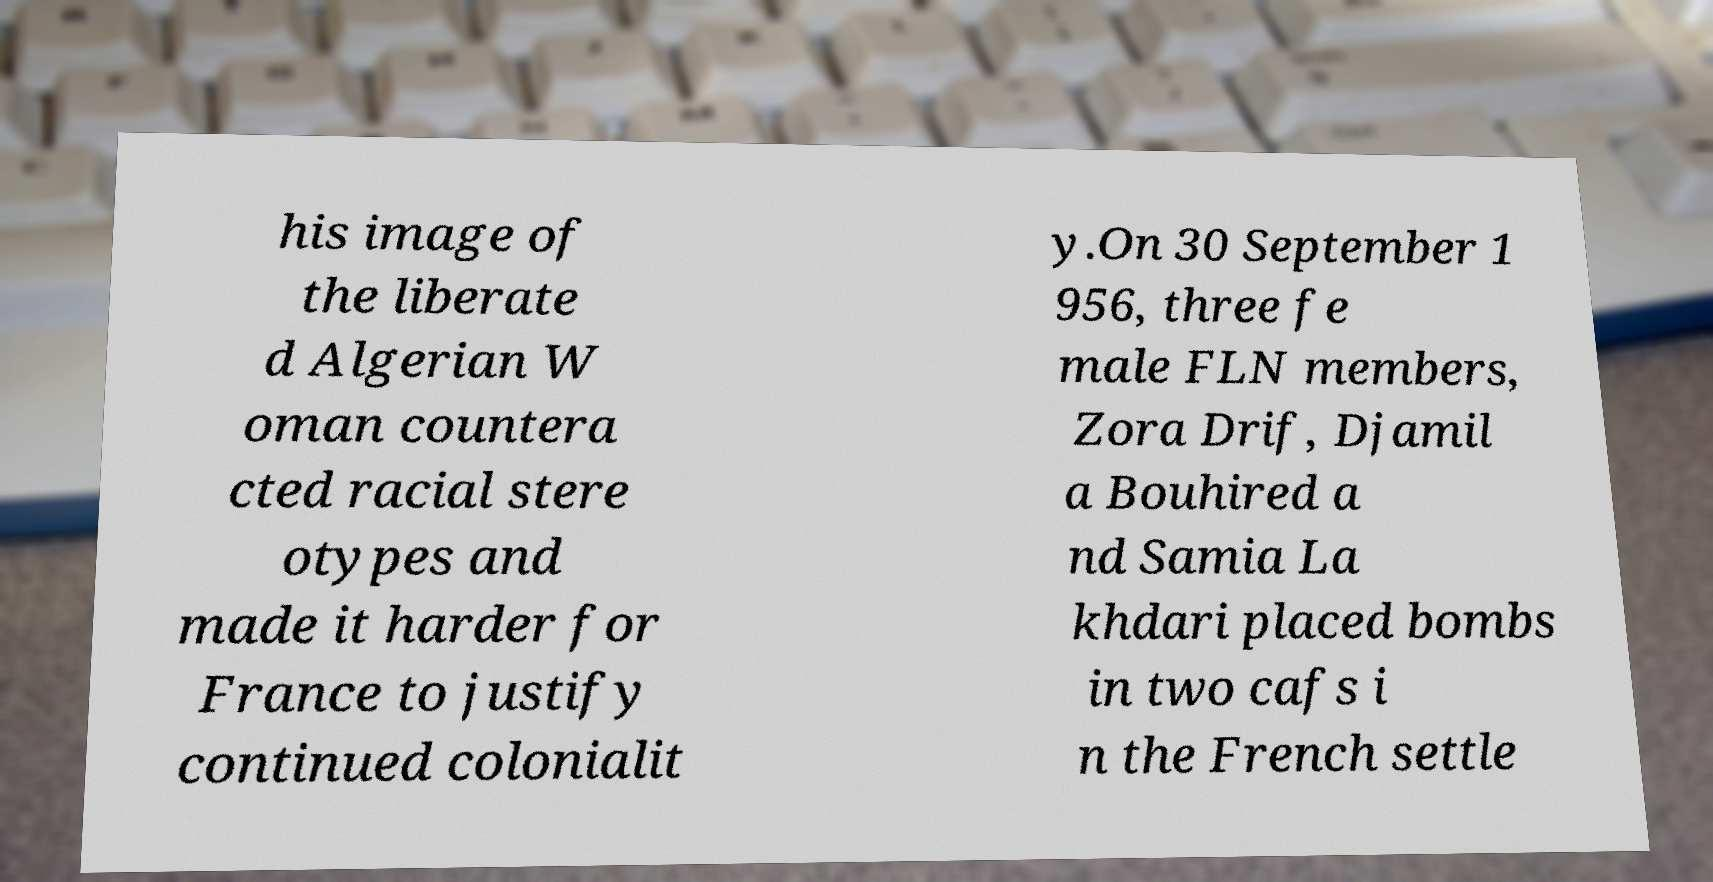There's text embedded in this image that I need extracted. Can you transcribe it verbatim? his image of the liberate d Algerian W oman countera cted racial stere otypes and made it harder for France to justify continued colonialit y.On 30 September 1 956, three fe male FLN members, Zora Drif, Djamil a Bouhired a nd Samia La khdari placed bombs in two cafs i n the French settle 